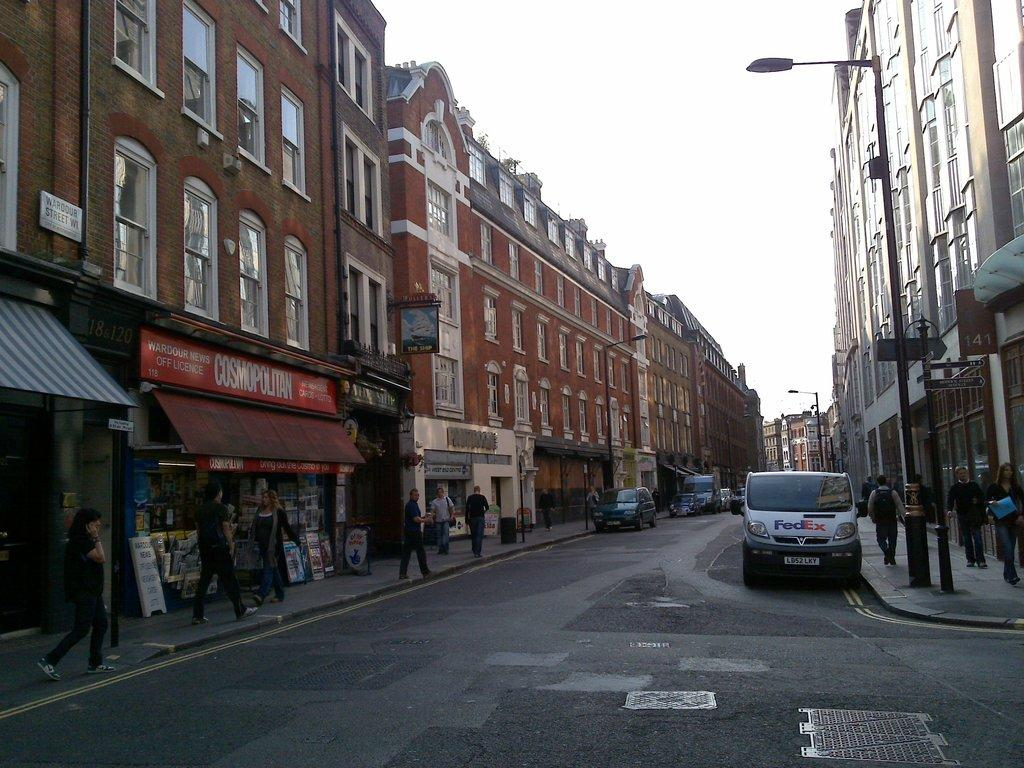What type of structures can be seen in the image? There are buildings in the image. Are there any people present in the image? Yes, there are people in the image. What type of establishments can be found in the image? There are stores in the image. What mode of transportation can be seen in the image? There are vehicles in the image. What type of lighting is present in the image? There are street lights in the image. What type of vertical structures can be seen in the image? There are poles in the image. What can be seen in the background of the image? The sky is visible in the background of the image. Can you tell me the size of the mountain in the image? There is no mountain present in the image. What type of stop sign can be seen in the image? There is no stop sign present in the image. 